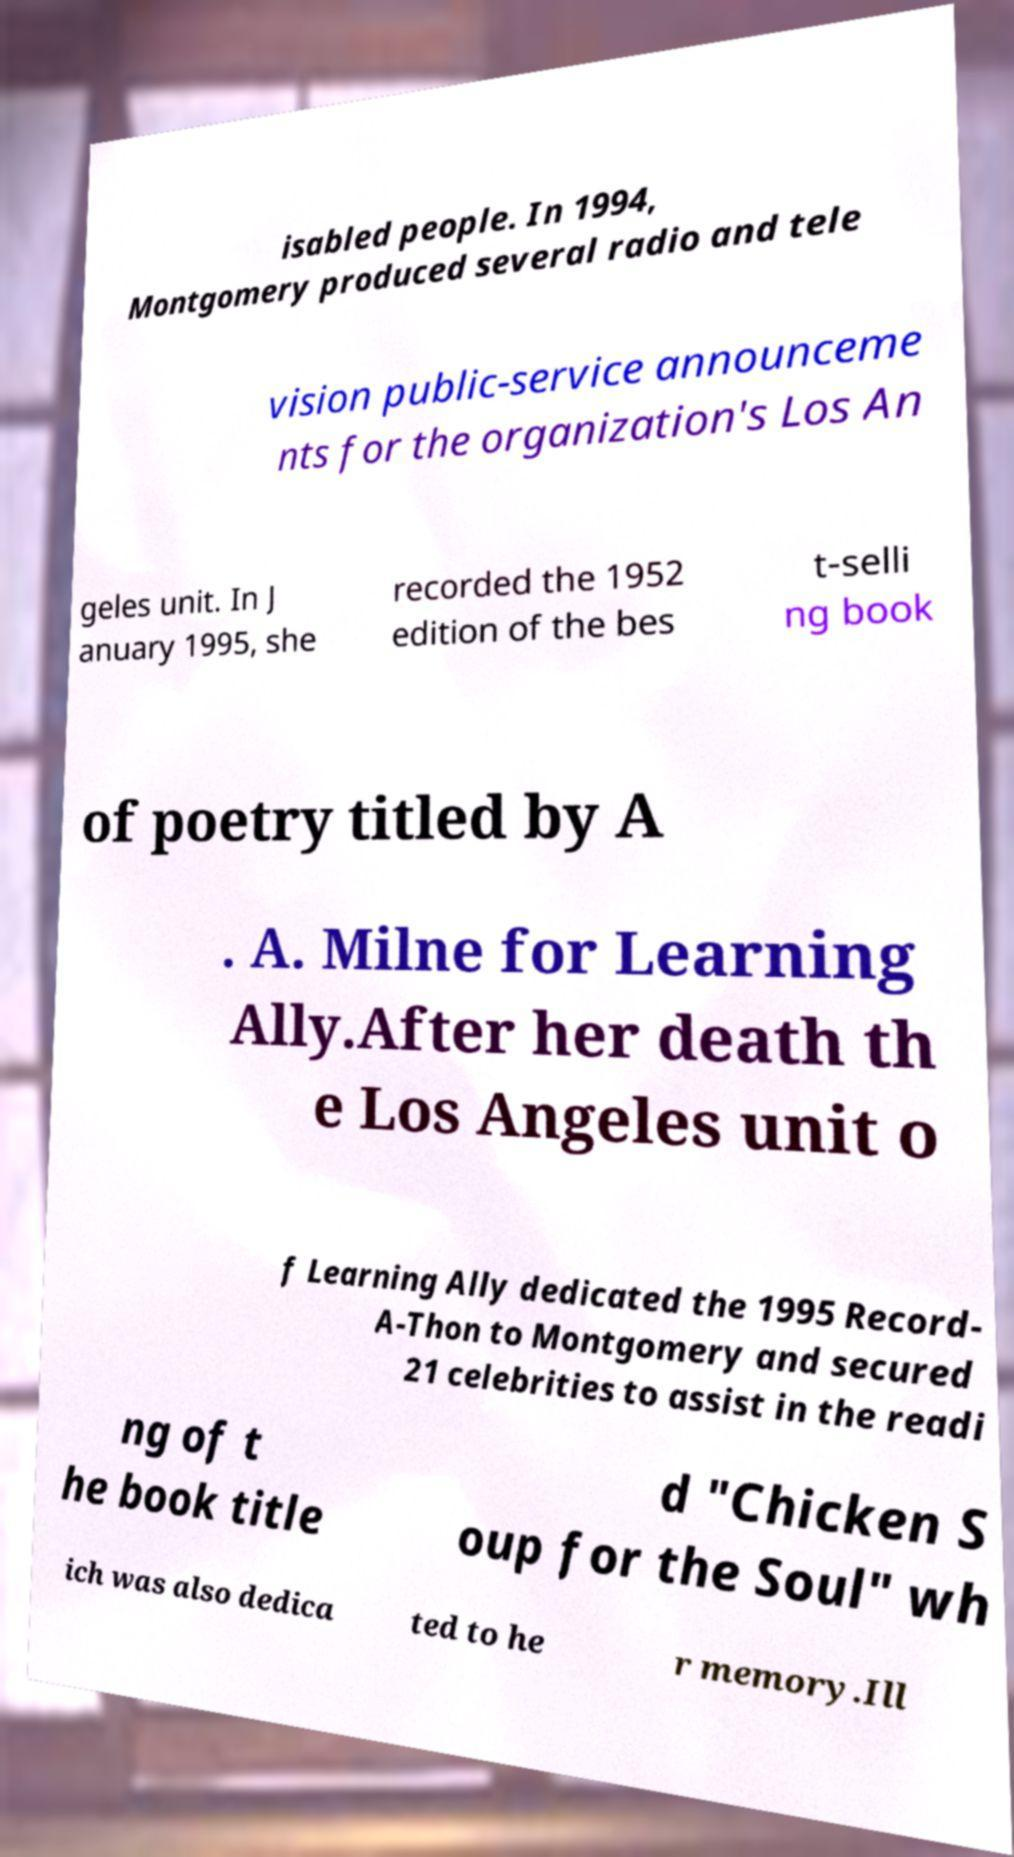Please read and relay the text visible in this image. What does it say? isabled people. In 1994, Montgomery produced several radio and tele vision public-service announceme nts for the organization's Los An geles unit. In J anuary 1995, she recorded the 1952 edition of the bes t-selli ng book of poetry titled by A . A. Milne for Learning Ally.After her death th e Los Angeles unit o f Learning Ally dedicated the 1995 Record- A-Thon to Montgomery and secured 21 celebrities to assist in the readi ng of t he book title d "Chicken S oup for the Soul" wh ich was also dedica ted to he r memory.Ill 